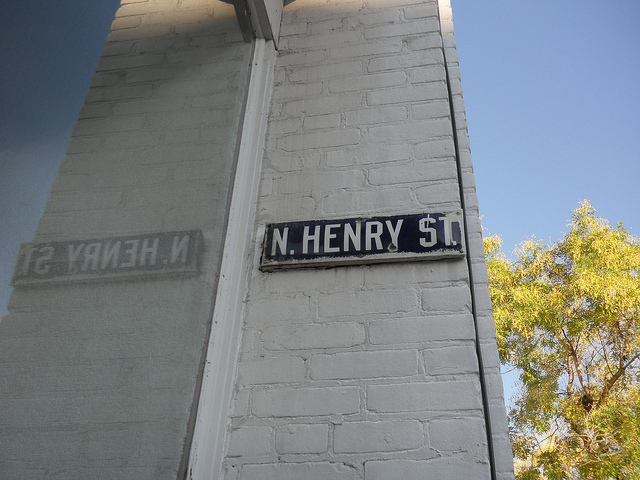Identify the text contained in this image. ST HENRY N ST HENRV N 